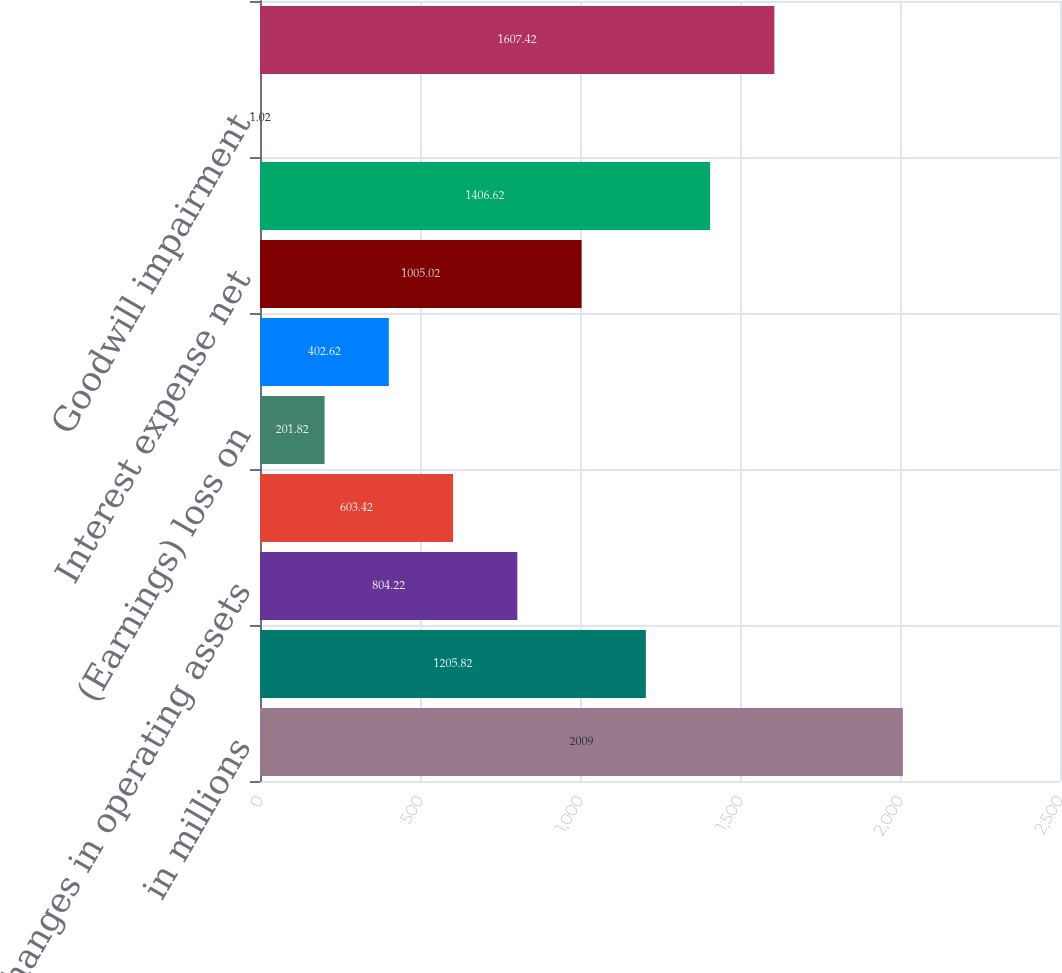Convert chart. <chart><loc_0><loc_0><loc_500><loc_500><bar_chart><fcel>in millions<fcel>Net cash provided by operating<fcel>Changes in operating assets<fcel>Other net operating items<fcel>(Earnings) loss on<fcel>Provision (benefit) for income<fcel>Interest expense net<fcel>EBITDA<fcel>Goodwill impairment<fcel>Adjusted EBITDA<nl><fcel>2009<fcel>1205.82<fcel>804.22<fcel>603.42<fcel>201.82<fcel>402.62<fcel>1005.02<fcel>1406.62<fcel>1.02<fcel>1607.42<nl></chart> 